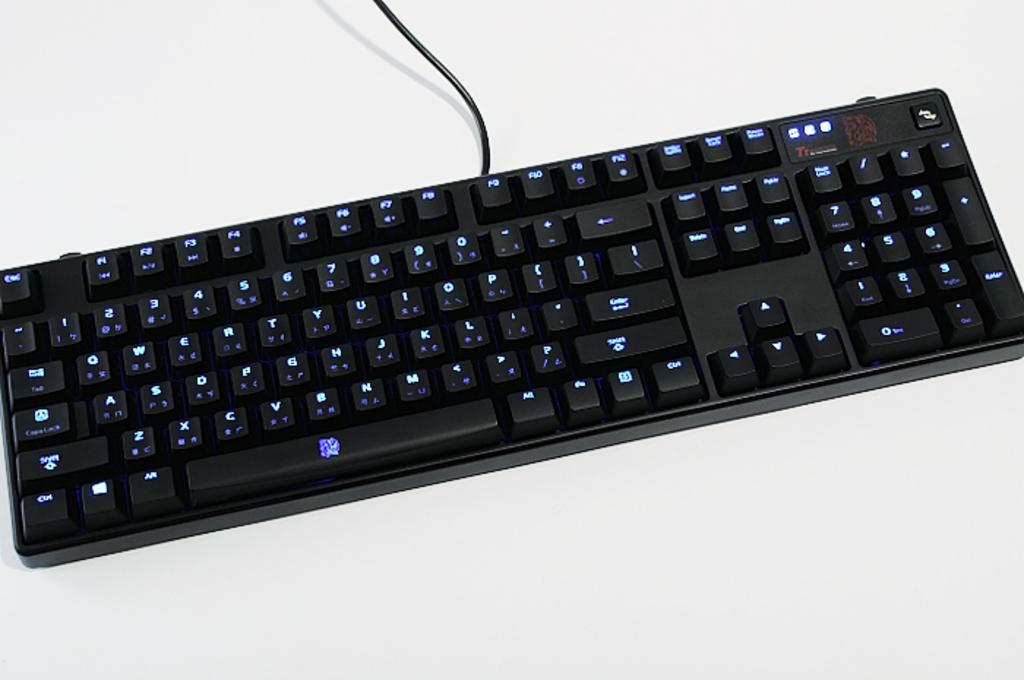What electronic device is visible in the image? There is a keyboard in the image. Does the keyboard have any connection to a power source or device? Yes, the keyboard has a wire. On what surface is the keyboard placed? The keyboard is present on a surface. What type of waves can be seen crashing on the shore in the image? There are no waves or shore visible in the image; it features a keyboard with a wire on a surface. 